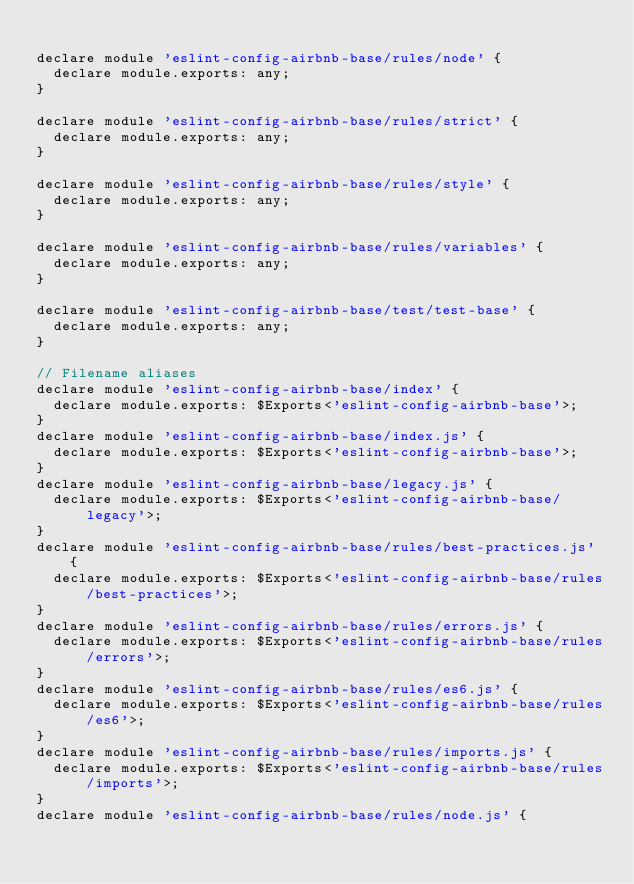<code> <loc_0><loc_0><loc_500><loc_500><_JavaScript_>
declare module 'eslint-config-airbnb-base/rules/node' {
  declare module.exports: any;
}

declare module 'eslint-config-airbnb-base/rules/strict' {
  declare module.exports: any;
}

declare module 'eslint-config-airbnb-base/rules/style' {
  declare module.exports: any;
}

declare module 'eslint-config-airbnb-base/rules/variables' {
  declare module.exports: any;
}

declare module 'eslint-config-airbnb-base/test/test-base' {
  declare module.exports: any;
}

// Filename aliases
declare module 'eslint-config-airbnb-base/index' {
  declare module.exports: $Exports<'eslint-config-airbnb-base'>;
}
declare module 'eslint-config-airbnb-base/index.js' {
  declare module.exports: $Exports<'eslint-config-airbnb-base'>;
}
declare module 'eslint-config-airbnb-base/legacy.js' {
  declare module.exports: $Exports<'eslint-config-airbnb-base/legacy'>;
}
declare module 'eslint-config-airbnb-base/rules/best-practices.js' {
  declare module.exports: $Exports<'eslint-config-airbnb-base/rules/best-practices'>;
}
declare module 'eslint-config-airbnb-base/rules/errors.js' {
  declare module.exports: $Exports<'eslint-config-airbnb-base/rules/errors'>;
}
declare module 'eslint-config-airbnb-base/rules/es6.js' {
  declare module.exports: $Exports<'eslint-config-airbnb-base/rules/es6'>;
}
declare module 'eslint-config-airbnb-base/rules/imports.js' {
  declare module.exports: $Exports<'eslint-config-airbnb-base/rules/imports'>;
}
declare module 'eslint-config-airbnb-base/rules/node.js' {</code> 